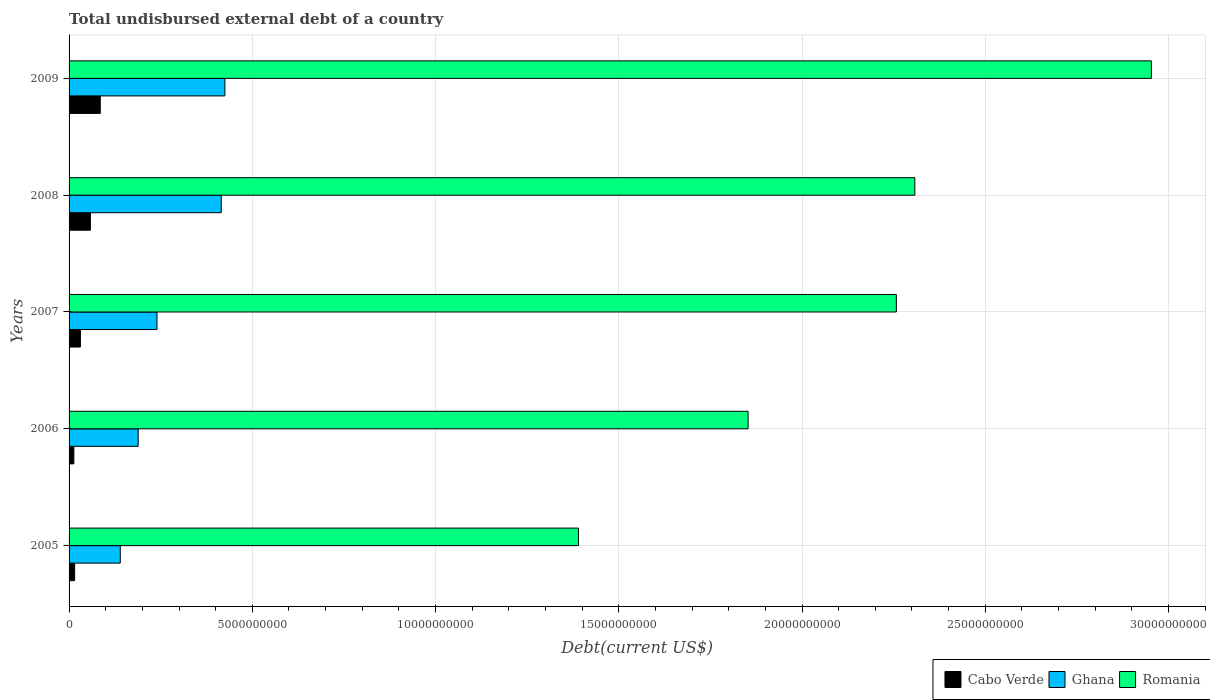In how many cases, is the number of bars for a given year not equal to the number of legend labels?
Your response must be concise. 0. What is the total undisbursed external debt in Cabo Verde in 2007?
Provide a short and direct response. 3.10e+08. Across all years, what is the maximum total undisbursed external debt in Ghana?
Your answer should be very brief. 4.25e+09. Across all years, what is the minimum total undisbursed external debt in Ghana?
Give a very brief answer. 1.40e+09. In which year was the total undisbursed external debt in Cabo Verde maximum?
Ensure brevity in your answer.  2009. In which year was the total undisbursed external debt in Ghana minimum?
Your answer should be compact. 2005. What is the total total undisbursed external debt in Romania in the graph?
Offer a very short reply. 1.08e+11. What is the difference between the total undisbursed external debt in Romania in 2005 and that in 2007?
Your answer should be compact. -8.67e+09. What is the difference between the total undisbursed external debt in Ghana in 2006 and the total undisbursed external debt in Romania in 2009?
Offer a very short reply. -2.76e+1. What is the average total undisbursed external debt in Romania per year?
Keep it short and to the point. 2.15e+1. In the year 2006, what is the difference between the total undisbursed external debt in Cabo Verde and total undisbursed external debt in Ghana?
Provide a succinct answer. -1.75e+09. In how many years, is the total undisbursed external debt in Ghana greater than 5000000000 US$?
Offer a terse response. 0. What is the ratio of the total undisbursed external debt in Ghana in 2006 to that in 2009?
Keep it short and to the point. 0.44. What is the difference between the highest and the second highest total undisbursed external debt in Romania?
Ensure brevity in your answer.  6.45e+09. What is the difference between the highest and the lowest total undisbursed external debt in Romania?
Keep it short and to the point. 1.56e+1. In how many years, is the total undisbursed external debt in Ghana greater than the average total undisbursed external debt in Ghana taken over all years?
Keep it short and to the point. 2. Is the sum of the total undisbursed external debt in Cabo Verde in 2005 and 2006 greater than the maximum total undisbursed external debt in Ghana across all years?
Your answer should be compact. No. What does the 2nd bar from the top in 2007 represents?
Keep it short and to the point. Ghana. Is it the case that in every year, the sum of the total undisbursed external debt in Cabo Verde and total undisbursed external debt in Ghana is greater than the total undisbursed external debt in Romania?
Keep it short and to the point. No. Are all the bars in the graph horizontal?
Keep it short and to the point. Yes. What is the difference between two consecutive major ticks on the X-axis?
Offer a terse response. 5.00e+09. Are the values on the major ticks of X-axis written in scientific E-notation?
Your answer should be very brief. No. Does the graph contain any zero values?
Make the answer very short. No. How are the legend labels stacked?
Provide a succinct answer. Horizontal. What is the title of the graph?
Ensure brevity in your answer.  Total undisbursed external debt of a country. What is the label or title of the X-axis?
Offer a very short reply. Debt(current US$). What is the label or title of the Y-axis?
Keep it short and to the point. Years. What is the Debt(current US$) of Cabo Verde in 2005?
Your answer should be compact. 1.53e+08. What is the Debt(current US$) of Ghana in 2005?
Your response must be concise. 1.40e+09. What is the Debt(current US$) of Romania in 2005?
Keep it short and to the point. 1.39e+1. What is the Debt(current US$) of Cabo Verde in 2006?
Your response must be concise. 1.31e+08. What is the Debt(current US$) of Ghana in 2006?
Your response must be concise. 1.89e+09. What is the Debt(current US$) in Romania in 2006?
Make the answer very short. 1.85e+1. What is the Debt(current US$) in Cabo Verde in 2007?
Your response must be concise. 3.10e+08. What is the Debt(current US$) of Ghana in 2007?
Offer a terse response. 2.40e+09. What is the Debt(current US$) in Romania in 2007?
Ensure brevity in your answer.  2.26e+1. What is the Debt(current US$) in Cabo Verde in 2008?
Provide a short and direct response. 5.82e+08. What is the Debt(current US$) of Ghana in 2008?
Your response must be concise. 4.15e+09. What is the Debt(current US$) of Romania in 2008?
Offer a very short reply. 2.31e+1. What is the Debt(current US$) in Cabo Verde in 2009?
Keep it short and to the point. 8.51e+08. What is the Debt(current US$) in Ghana in 2009?
Your answer should be very brief. 4.25e+09. What is the Debt(current US$) in Romania in 2009?
Provide a succinct answer. 2.95e+1. Across all years, what is the maximum Debt(current US$) of Cabo Verde?
Offer a very short reply. 8.51e+08. Across all years, what is the maximum Debt(current US$) of Ghana?
Keep it short and to the point. 4.25e+09. Across all years, what is the maximum Debt(current US$) in Romania?
Provide a short and direct response. 2.95e+1. Across all years, what is the minimum Debt(current US$) in Cabo Verde?
Your answer should be compact. 1.31e+08. Across all years, what is the minimum Debt(current US$) of Ghana?
Offer a very short reply. 1.40e+09. Across all years, what is the minimum Debt(current US$) of Romania?
Provide a short and direct response. 1.39e+1. What is the total Debt(current US$) of Cabo Verde in the graph?
Offer a very short reply. 2.03e+09. What is the total Debt(current US$) in Ghana in the graph?
Your answer should be compact. 1.41e+1. What is the total Debt(current US$) of Romania in the graph?
Offer a very short reply. 1.08e+11. What is the difference between the Debt(current US$) of Cabo Verde in 2005 and that in 2006?
Your answer should be compact. 2.17e+07. What is the difference between the Debt(current US$) in Ghana in 2005 and that in 2006?
Provide a succinct answer. -4.88e+08. What is the difference between the Debt(current US$) in Romania in 2005 and that in 2006?
Offer a very short reply. -4.63e+09. What is the difference between the Debt(current US$) in Cabo Verde in 2005 and that in 2007?
Provide a succinct answer. -1.57e+08. What is the difference between the Debt(current US$) of Ghana in 2005 and that in 2007?
Make the answer very short. -1.00e+09. What is the difference between the Debt(current US$) in Romania in 2005 and that in 2007?
Offer a very short reply. -8.67e+09. What is the difference between the Debt(current US$) of Cabo Verde in 2005 and that in 2008?
Keep it short and to the point. -4.29e+08. What is the difference between the Debt(current US$) of Ghana in 2005 and that in 2008?
Provide a short and direct response. -2.75e+09. What is the difference between the Debt(current US$) in Romania in 2005 and that in 2008?
Your answer should be very brief. -9.18e+09. What is the difference between the Debt(current US$) of Cabo Verde in 2005 and that in 2009?
Offer a very short reply. -6.99e+08. What is the difference between the Debt(current US$) of Ghana in 2005 and that in 2009?
Offer a terse response. -2.85e+09. What is the difference between the Debt(current US$) in Romania in 2005 and that in 2009?
Your answer should be very brief. -1.56e+1. What is the difference between the Debt(current US$) of Cabo Verde in 2006 and that in 2007?
Give a very brief answer. -1.79e+08. What is the difference between the Debt(current US$) of Ghana in 2006 and that in 2007?
Offer a very short reply. -5.13e+08. What is the difference between the Debt(current US$) of Romania in 2006 and that in 2007?
Give a very brief answer. -4.04e+09. What is the difference between the Debt(current US$) of Cabo Verde in 2006 and that in 2008?
Ensure brevity in your answer.  -4.51e+08. What is the difference between the Debt(current US$) in Ghana in 2006 and that in 2008?
Your answer should be compact. -2.27e+09. What is the difference between the Debt(current US$) of Romania in 2006 and that in 2008?
Make the answer very short. -4.55e+09. What is the difference between the Debt(current US$) in Cabo Verde in 2006 and that in 2009?
Offer a very short reply. -7.20e+08. What is the difference between the Debt(current US$) of Ghana in 2006 and that in 2009?
Provide a short and direct response. -2.37e+09. What is the difference between the Debt(current US$) of Romania in 2006 and that in 2009?
Offer a very short reply. -1.10e+1. What is the difference between the Debt(current US$) in Cabo Verde in 2007 and that in 2008?
Keep it short and to the point. -2.72e+08. What is the difference between the Debt(current US$) in Ghana in 2007 and that in 2008?
Provide a succinct answer. -1.75e+09. What is the difference between the Debt(current US$) in Romania in 2007 and that in 2008?
Your answer should be very brief. -5.05e+08. What is the difference between the Debt(current US$) of Cabo Verde in 2007 and that in 2009?
Provide a succinct answer. -5.41e+08. What is the difference between the Debt(current US$) of Ghana in 2007 and that in 2009?
Your answer should be very brief. -1.85e+09. What is the difference between the Debt(current US$) in Romania in 2007 and that in 2009?
Offer a terse response. -6.96e+09. What is the difference between the Debt(current US$) of Cabo Verde in 2008 and that in 2009?
Give a very brief answer. -2.69e+08. What is the difference between the Debt(current US$) in Ghana in 2008 and that in 2009?
Your response must be concise. -9.99e+07. What is the difference between the Debt(current US$) in Romania in 2008 and that in 2009?
Provide a short and direct response. -6.45e+09. What is the difference between the Debt(current US$) in Cabo Verde in 2005 and the Debt(current US$) in Ghana in 2006?
Offer a terse response. -1.73e+09. What is the difference between the Debt(current US$) of Cabo Verde in 2005 and the Debt(current US$) of Romania in 2006?
Your answer should be compact. -1.84e+1. What is the difference between the Debt(current US$) of Ghana in 2005 and the Debt(current US$) of Romania in 2006?
Give a very brief answer. -1.71e+1. What is the difference between the Debt(current US$) in Cabo Verde in 2005 and the Debt(current US$) in Ghana in 2007?
Your response must be concise. -2.25e+09. What is the difference between the Debt(current US$) of Cabo Verde in 2005 and the Debt(current US$) of Romania in 2007?
Your answer should be compact. -2.24e+1. What is the difference between the Debt(current US$) of Ghana in 2005 and the Debt(current US$) of Romania in 2007?
Ensure brevity in your answer.  -2.12e+1. What is the difference between the Debt(current US$) of Cabo Verde in 2005 and the Debt(current US$) of Ghana in 2008?
Give a very brief answer. -4.00e+09. What is the difference between the Debt(current US$) in Cabo Verde in 2005 and the Debt(current US$) in Romania in 2008?
Offer a terse response. -2.29e+1. What is the difference between the Debt(current US$) in Ghana in 2005 and the Debt(current US$) in Romania in 2008?
Provide a short and direct response. -2.17e+1. What is the difference between the Debt(current US$) of Cabo Verde in 2005 and the Debt(current US$) of Ghana in 2009?
Your answer should be very brief. -4.10e+09. What is the difference between the Debt(current US$) of Cabo Verde in 2005 and the Debt(current US$) of Romania in 2009?
Offer a very short reply. -2.94e+1. What is the difference between the Debt(current US$) of Ghana in 2005 and the Debt(current US$) of Romania in 2009?
Provide a short and direct response. -2.81e+1. What is the difference between the Debt(current US$) of Cabo Verde in 2006 and the Debt(current US$) of Ghana in 2007?
Give a very brief answer. -2.27e+09. What is the difference between the Debt(current US$) in Cabo Verde in 2006 and the Debt(current US$) in Romania in 2007?
Your answer should be compact. -2.24e+1. What is the difference between the Debt(current US$) of Ghana in 2006 and the Debt(current US$) of Romania in 2007?
Offer a very short reply. -2.07e+1. What is the difference between the Debt(current US$) of Cabo Verde in 2006 and the Debt(current US$) of Ghana in 2008?
Give a very brief answer. -4.02e+09. What is the difference between the Debt(current US$) in Cabo Verde in 2006 and the Debt(current US$) in Romania in 2008?
Ensure brevity in your answer.  -2.29e+1. What is the difference between the Debt(current US$) in Ghana in 2006 and the Debt(current US$) in Romania in 2008?
Keep it short and to the point. -2.12e+1. What is the difference between the Debt(current US$) of Cabo Verde in 2006 and the Debt(current US$) of Ghana in 2009?
Your answer should be compact. -4.12e+09. What is the difference between the Debt(current US$) in Cabo Verde in 2006 and the Debt(current US$) in Romania in 2009?
Make the answer very short. -2.94e+1. What is the difference between the Debt(current US$) of Ghana in 2006 and the Debt(current US$) of Romania in 2009?
Keep it short and to the point. -2.76e+1. What is the difference between the Debt(current US$) in Cabo Verde in 2007 and the Debt(current US$) in Ghana in 2008?
Your response must be concise. -3.84e+09. What is the difference between the Debt(current US$) of Cabo Verde in 2007 and the Debt(current US$) of Romania in 2008?
Ensure brevity in your answer.  -2.28e+1. What is the difference between the Debt(current US$) of Ghana in 2007 and the Debt(current US$) of Romania in 2008?
Your answer should be very brief. -2.07e+1. What is the difference between the Debt(current US$) in Cabo Verde in 2007 and the Debt(current US$) in Ghana in 2009?
Offer a very short reply. -3.94e+09. What is the difference between the Debt(current US$) of Cabo Verde in 2007 and the Debt(current US$) of Romania in 2009?
Your answer should be very brief. -2.92e+1. What is the difference between the Debt(current US$) of Ghana in 2007 and the Debt(current US$) of Romania in 2009?
Keep it short and to the point. -2.71e+1. What is the difference between the Debt(current US$) of Cabo Verde in 2008 and the Debt(current US$) of Ghana in 2009?
Your answer should be very brief. -3.67e+09. What is the difference between the Debt(current US$) of Cabo Verde in 2008 and the Debt(current US$) of Romania in 2009?
Offer a terse response. -2.90e+1. What is the difference between the Debt(current US$) in Ghana in 2008 and the Debt(current US$) in Romania in 2009?
Provide a short and direct response. -2.54e+1. What is the average Debt(current US$) of Cabo Verde per year?
Your answer should be compact. 4.05e+08. What is the average Debt(current US$) of Ghana per year?
Keep it short and to the point. 2.82e+09. What is the average Debt(current US$) of Romania per year?
Make the answer very short. 2.15e+1. In the year 2005, what is the difference between the Debt(current US$) of Cabo Verde and Debt(current US$) of Ghana?
Keep it short and to the point. -1.24e+09. In the year 2005, what is the difference between the Debt(current US$) of Cabo Verde and Debt(current US$) of Romania?
Your answer should be compact. -1.37e+1. In the year 2005, what is the difference between the Debt(current US$) of Ghana and Debt(current US$) of Romania?
Your answer should be very brief. -1.25e+1. In the year 2006, what is the difference between the Debt(current US$) in Cabo Verde and Debt(current US$) in Ghana?
Your answer should be compact. -1.75e+09. In the year 2006, what is the difference between the Debt(current US$) of Cabo Verde and Debt(current US$) of Romania?
Provide a succinct answer. -1.84e+1. In the year 2006, what is the difference between the Debt(current US$) in Ghana and Debt(current US$) in Romania?
Offer a very short reply. -1.66e+1. In the year 2007, what is the difference between the Debt(current US$) in Cabo Verde and Debt(current US$) in Ghana?
Your answer should be very brief. -2.09e+09. In the year 2007, what is the difference between the Debt(current US$) of Cabo Verde and Debt(current US$) of Romania?
Keep it short and to the point. -2.23e+1. In the year 2007, what is the difference between the Debt(current US$) of Ghana and Debt(current US$) of Romania?
Ensure brevity in your answer.  -2.02e+1. In the year 2008, what is the difference between the Debt(current US$) in Cabo Verde and Debt(current US$) in Ghana?
Give a very brief answer. -3.57e+09. In the year 2008, what is the difference between the Debt(current US$) of Cabo Verde and Debt(current US$) of Romania?
Keep it short and to the point. -2.25e+1. In the year 2008, what is the difference between the Debt(current US$) of Ghana and Debt(current US$) of Romania?
Your answer should be very brief. -1.89e+1. In the year 2009, what is the difference between the Debt(current US$) in Cabo Verde and Debt(current US$) in Ghana?
Provide a short and direct response. -3.40e+09. In the year 2009, what is the difference between the Debt(current US$) in Cabo Verde and Debt(current US$) in Romania?
Offer a terse response. -2.87e+1. In the year 2009, what is the difference between the Debt(current US$) of Ghana and Debt(current US$) of Romania?
Give a very brief answer. -2.53e+1. What is the ratio of the Debt(current US$) of Cabo Verde in 2005 to that in 2006?
Make the answer very short. 1.17. What is the ratio of the Debt(current US$) in Ghana in 2005 to that in 2006?
Give a very brief answer. 0.74. What is the ratio of the Debt(current US$) of Romania in 2005 to that in 2006?
Provide a short and direct response. 0.75. What is the ratio of the Debt(current US$) in Cabo Verde in 2005 to that in 2007?
Keep it short and to the point. 0.49. What is the ratio of the Debt(current US$) of Ghana in 2005 to that in 2007?
Your answer should be compact. 0.58. What is the ratio of the Debt(current US$) in Romania in 2005 to that in 2007?
Offer a terse response. 0.62. What is the ratio of the Debt(current US$) in Cabo Verde in 2005 to that in 2008?
Keep it short and to the point. 0.26. What is the ratio of the Debt(current US$) of Ghana in 2005 to that in 2008?
Your answer should be compact. 0.34. What is the ratio of the Debt(current US$) in Romania in 2005 to that in 2008?
Your response must be concise. 0.6. What is the ratio of the Debt(current US$) in Cabo Verde in 2005 to that in 2009?
Your response must be concise. 0.18. What is the ratio of the Debt(current US$) in Ghana in 2005 to that in 2009?
Keep it short and to the point. 0.33. What is the ratio of the Debt(current US$) of Romania in 2005 to that in 2009?
Provide a short and direct response. 0.47. What is the ratio of the Debt(current US$) of Cabo Verde in 2006 to that in 2007?
Ensure brevity in your answer.  0.42. What is the ratio of the Debt(current US$) in Ghana in 2006 to that in 2007?
Give a very brief answer. 0.79. What is the ratio of the Debt(current US$) in Romania in 2006 to that in 2007?
Your response must be concise. 0.82. What is the ratio of the Debt(current US$) of Cabo Verde in 2006 to that in 2008?
Your answer should be compact. 0.22. What is the ratio of the Debt(current US$) of Ghana in 2006 to that in 2008?
Offer a very short reply. 0.45. What is the ratio of the Debt(current US$) in Romania in 2006 to that in 2008?
Your answer should be compact. 0.8. What is the ratio of the Debt(current US$) of Cabo Verde in 2006 to that in 2009?
Give a very brief answer. 0.15. What is the ratio of the Debt(current US$) of Ghana in 2006 to that in 2009?
Offer a very short reply. 0.44. What is the ratio of the Debt(current US$) of Romania in 2006 to that in 2009?
Ensure brevity in your answer.  0.63. What is the ratio of the Debt(current US$) of Cabo Verde in 2007 to that in 2008?
Your response must be concise. 0.53. What is the ratio of the Debt(current US$) in Ghana in 2007 to that in 2008?
Your answer should be compact. 0.58. What is the ratio of the Debt(current US$) of Romania in 2007 to that in 2008?
Provide a succinct answer. 0.98. What is the ratio of the Debt(current US$) of Cabo Verde in 2007 to that in 2009?
Give a very brief answer. 0.36. What is the ratio of the Debt(current US$) of Ghana in 2007 to that in 2009?
Provide a succinct answer. 0.56. What is the ratio of the Debt(current US$) in Romania in 2007 to that in 2009?
Give a very brief answer. 0.76. What is the ratio of the Debt(current US$) in Cabo Verde in 2008 to that in 2009?
Keep it short and to the point. 0.68. What is the ratio of the Debt(current US$) of Ghana in 2008 to that in 2009?
Your answer should be compact. 0.98. What is the ratio of the Debt(current US$) of Romania in 2008 to that in 2009?
Your response must be concise. 0.78. What is the difference between the highest and the second highest Debt(current US$) in Cabo Verde?
Your response must be concise. 2.69e+08. What is the difference between the highest and the second highest Debt(current US$) in Ghana?
Provide a succinct answer. 9.99e+07. What is the difference between the highest and the second highest Debt(current US$) of Romania?
Your response must be concise. 6.45e+09. What is the difference between the highest and the lowest Debt(current US$) of Cabo Verde?
Ensure brevity in your answer.  7.20e+08. What is the difference between the highest and the lowest Debt(current US$) in Ghana?
Ensure brevity in your answer.  2.85e+09. What is the difference between the highest and the lowest Debt(current US$) of Romania?
Provide a short and direct response. 1.56e+1. 